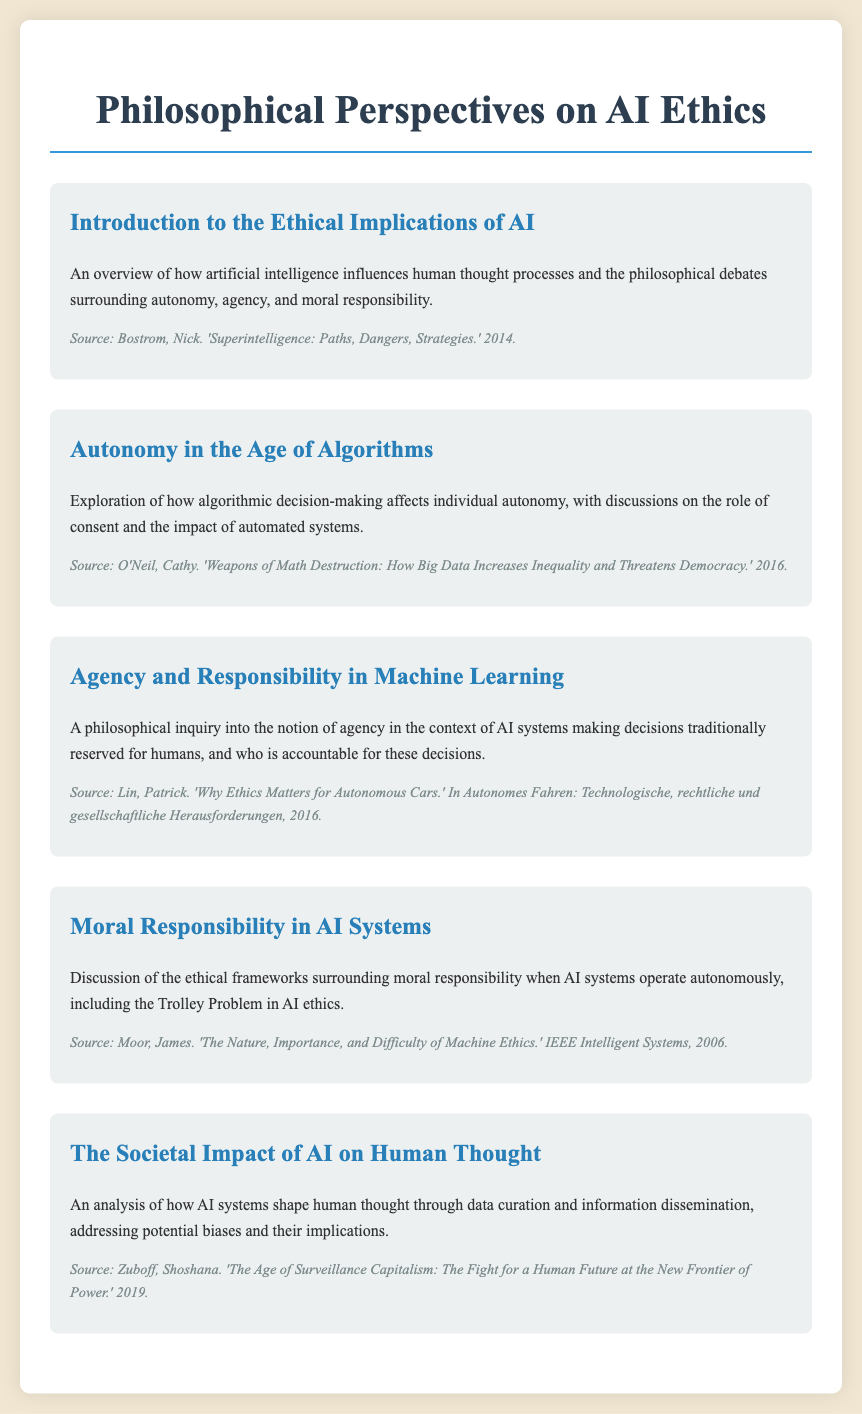What is the title of the document? The title of the document is found at the top of the rendered document and indicates its main focus on ethics and philosophy regarding AI.
Answer: Philosophical Perspectives on AI Ethics What year was "Weapons of Math Destruction" published? The publication year is mentioned as part of the source reference for the menu item related to autonomy and algorithms.
Answer: 2016 Who is the author of "Superintelligence: Paths, Dangers, Strategies"? The document mentions the author's name as part of the source citation for the introduction section, making it identifiable.
Answer: Nick Bostrom What ethical dilemma is discussed in the context of AI systems? The document highlights a well-known ethical scenario often used in philosophical discussions regarding moral responsibility in AI.
Answer: Trolley Problem Which source addresses the societal impact of AI? The source reference included in the relevant section discusses how AI systems influence thought through data and biases.
Answer: Shoshana Zuboff What role does consent play according to the section on autonomy? The text discusses this aspect as significant when evaluating the effects of algorithmic decision-making on individual autonomy.
Answer: Significant Which author contributes to the philosophical inquiry into agency in AI systems? The source provided for the agency and responsibility section identifies the author linked to this philosophical discussion about AI.
Answer: Patrick Lin How many menu items are presented in the document? The total count of distinct sections or menu items is needed to address this question regarding the structure of the document.
Answer: Five 